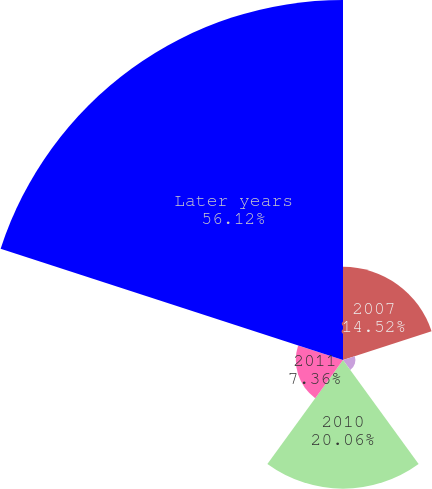Convert chart to OTSL. <chart><loc_0><loc_0><loc_500><loc_500><pie_chart><fcel>2007<fcel>2008<fcel>2010<fcel>2011<fcel>Later years<nl><fcel>14.52%<fcel>1.94%<fcel>20.06%<fcel>7.36%<fcel>56.13%<nl></chart> 